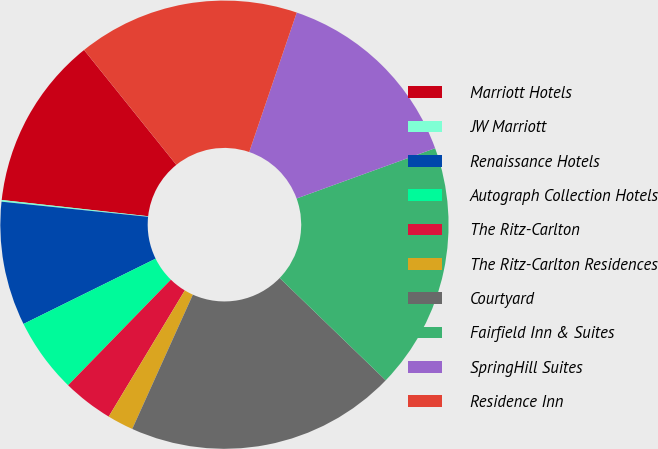<chart> <loc_0><loc_0><loc_500><loc_500><pie_chart><fcel>Marriott Hotels<fcel>JW Marriott<fcel>Renaissance Hotels<fcel>Autograph Collection Hotels<fcel>The Ritz-Carlton<fcel>The Ritz-Carlton Residences<fcel>Courtyard<fcel>Fairfield Inn & Suites<fcel>SpringHill Suites<fcel>Residence Inn<nl><fcel>12.47%<fcel>0.12%<fcel>8.94%<fcel>5.41%<fcel>3.65%<fcel>1.89%<fcel>19.53%<fcel>17.76%<fcel>14.23%<fcel>16.0%<nl></chart> 